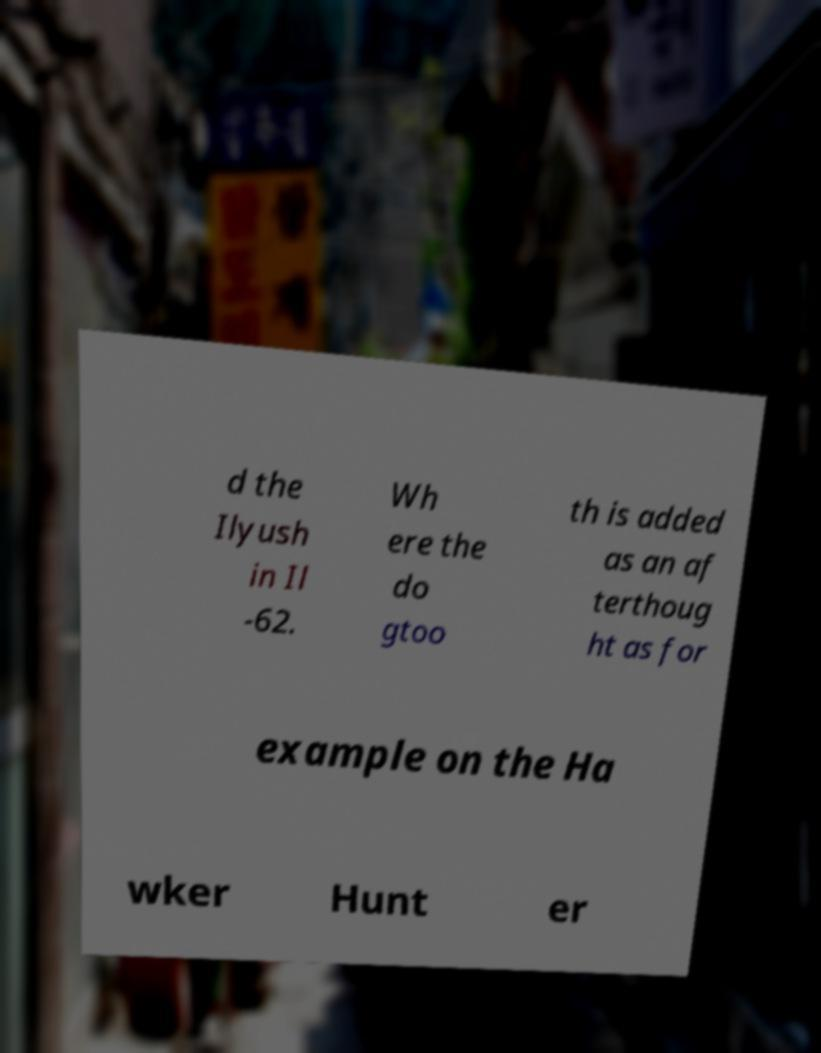Could you assist in decoding the text presented in this image and type it out clearly? d the Ilyush in Il -62. Wh ere the do gtoo th is added as an af terthoug ht as for example on the Ha wker Hunt er 